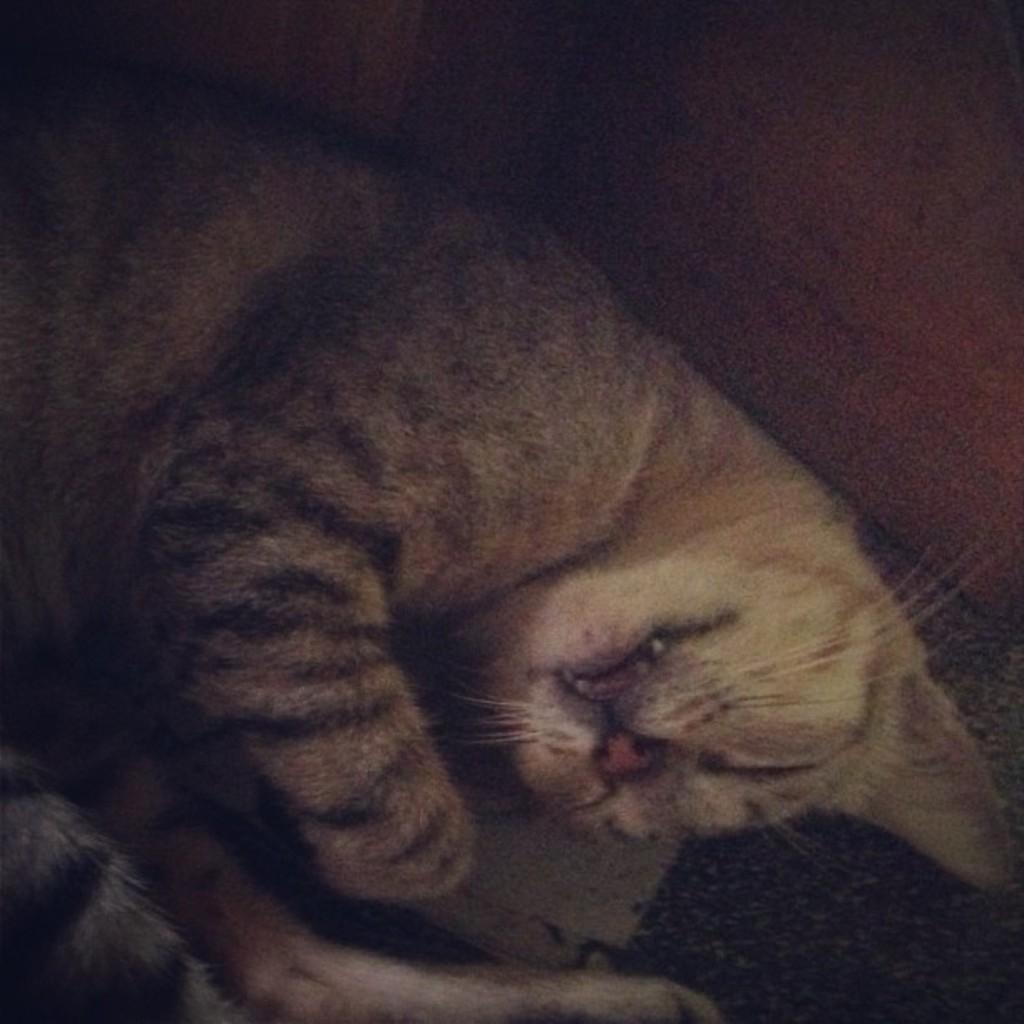How would you summarize this image in a sentence or two? In the picture there is a cat lying on the floor. 